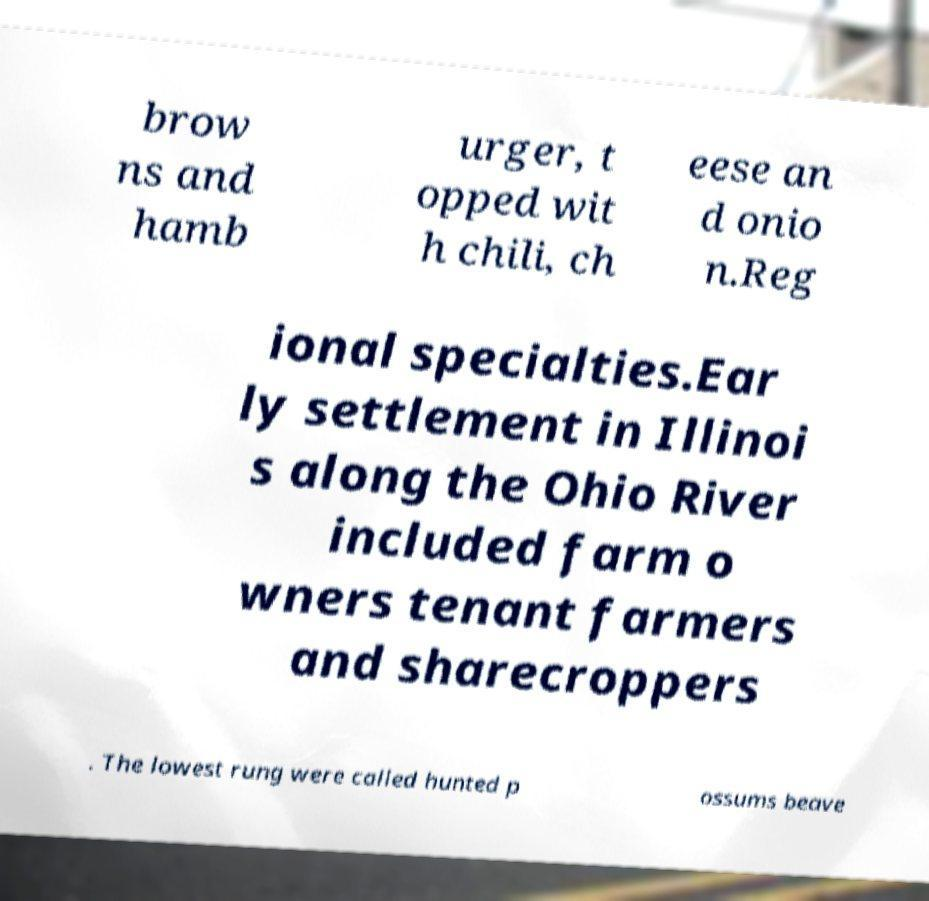Could you extract and type out the text from this image? brow ns and hamb urger, t opped wit h chili, ch eese an d onio n.Reg ional specialties.Ear ly settlement in Illinoi s along the Ohio River included farm o wners tenant farmers and sharecroppers . The lowest rung were called hunted p ossums beave 